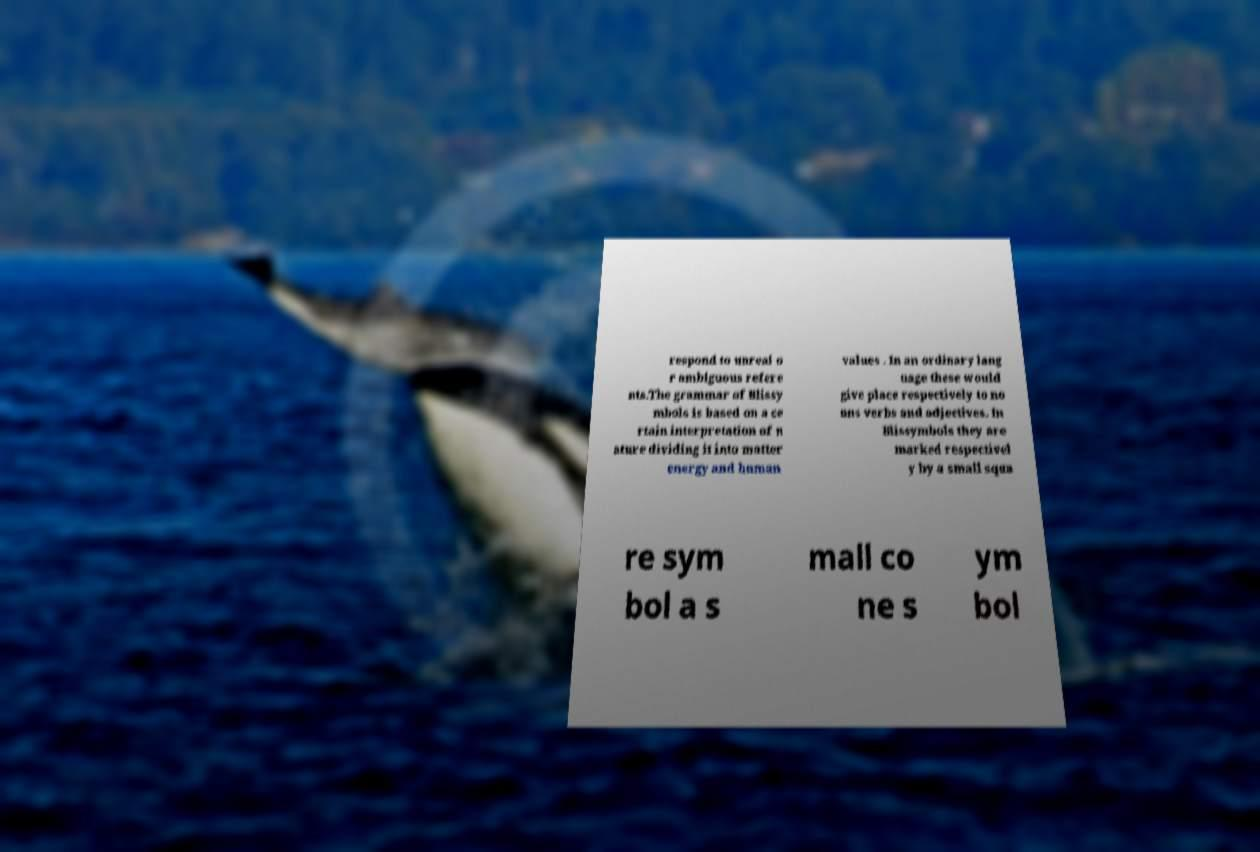There's text embedded in this image that I need extracted. Can you transcribe it verbatim? respond to unreal o r ambiguous refere nts.The grammar of Blissy mbols is based on a ce rtain interpretation of n ature dividing it into matter energy and human values . In an ordinary lang uage these would give place respectively to no uns verbs and adjectives. In Blissymbols they are marked respectivel y by a small squa re sym bol a s mall co ne s ym bol 